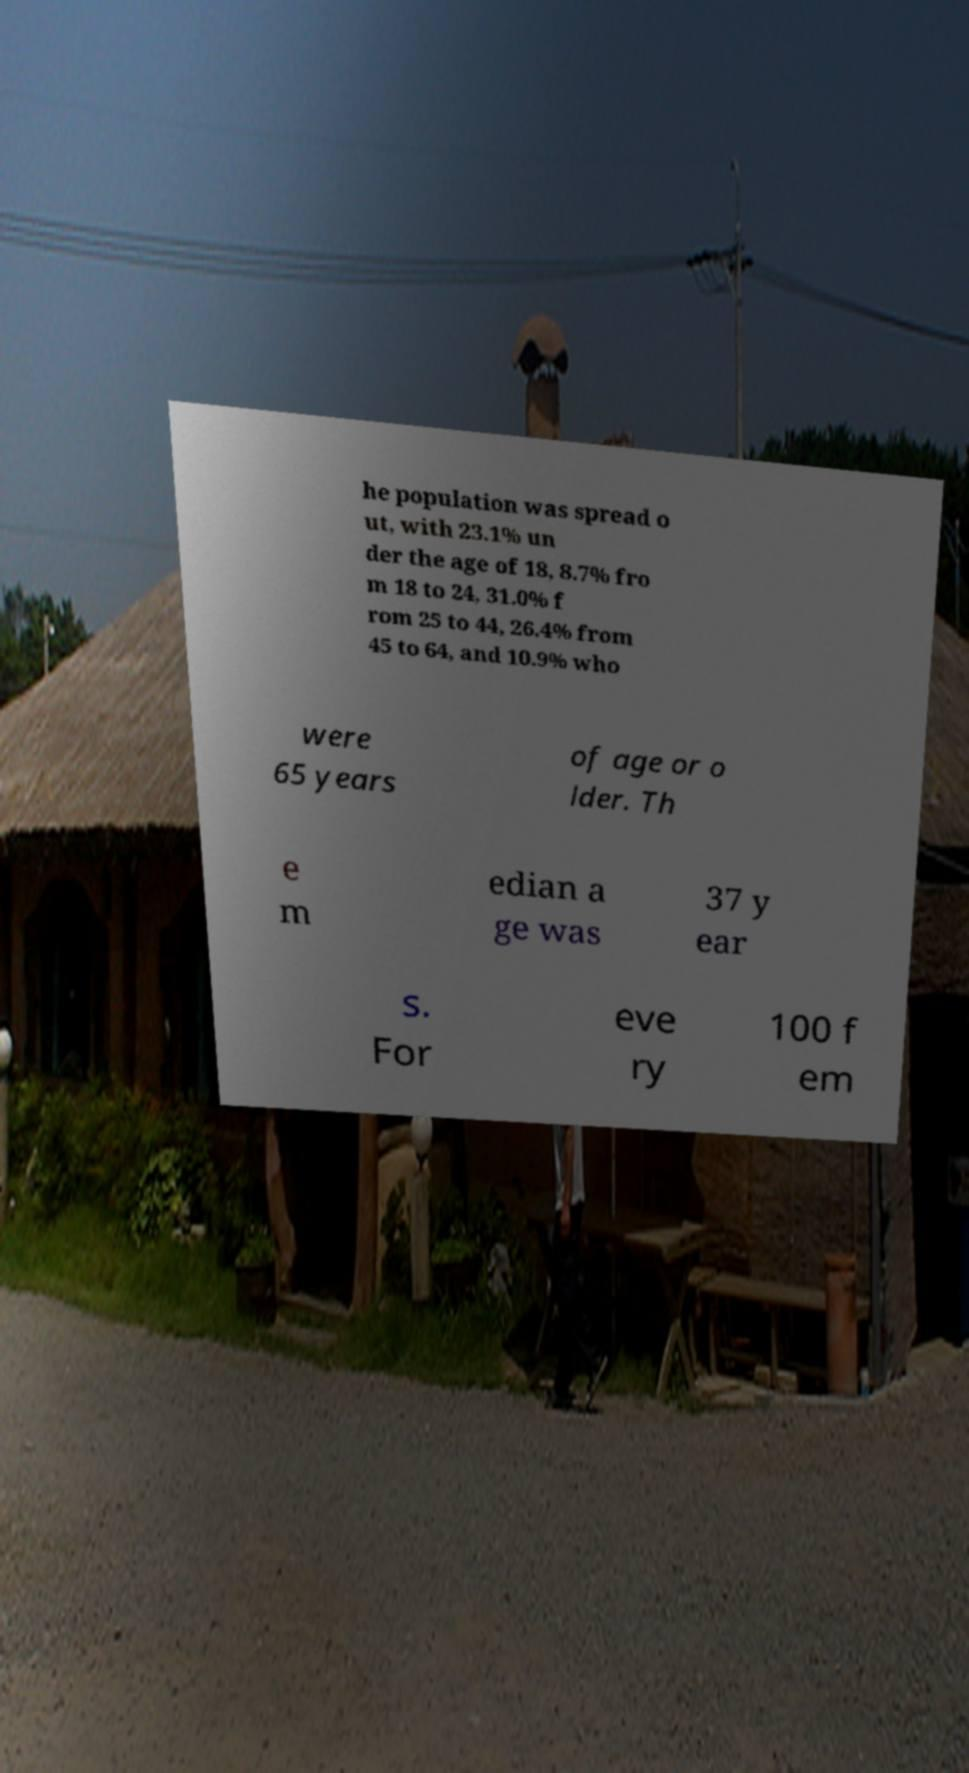I need the written content from this picture converted into text. Can you do that? he population was spread o ut, with 23.1% un der the age of 18, 8.7% fro m 18 to 24, 31.0% f rom 25 to 44, 26.4% from 45 to 64, and 10.9% who were 65 years of age or o lder. Th e m edian a ge was 37 y ear s. For eve ry 100 f em 